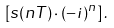<formula> <loc_0><loc_0><loc_500><loc_500>\left [ s ( n T ) \cdot ( - i ) ^ { n } \right ] .</formula> 